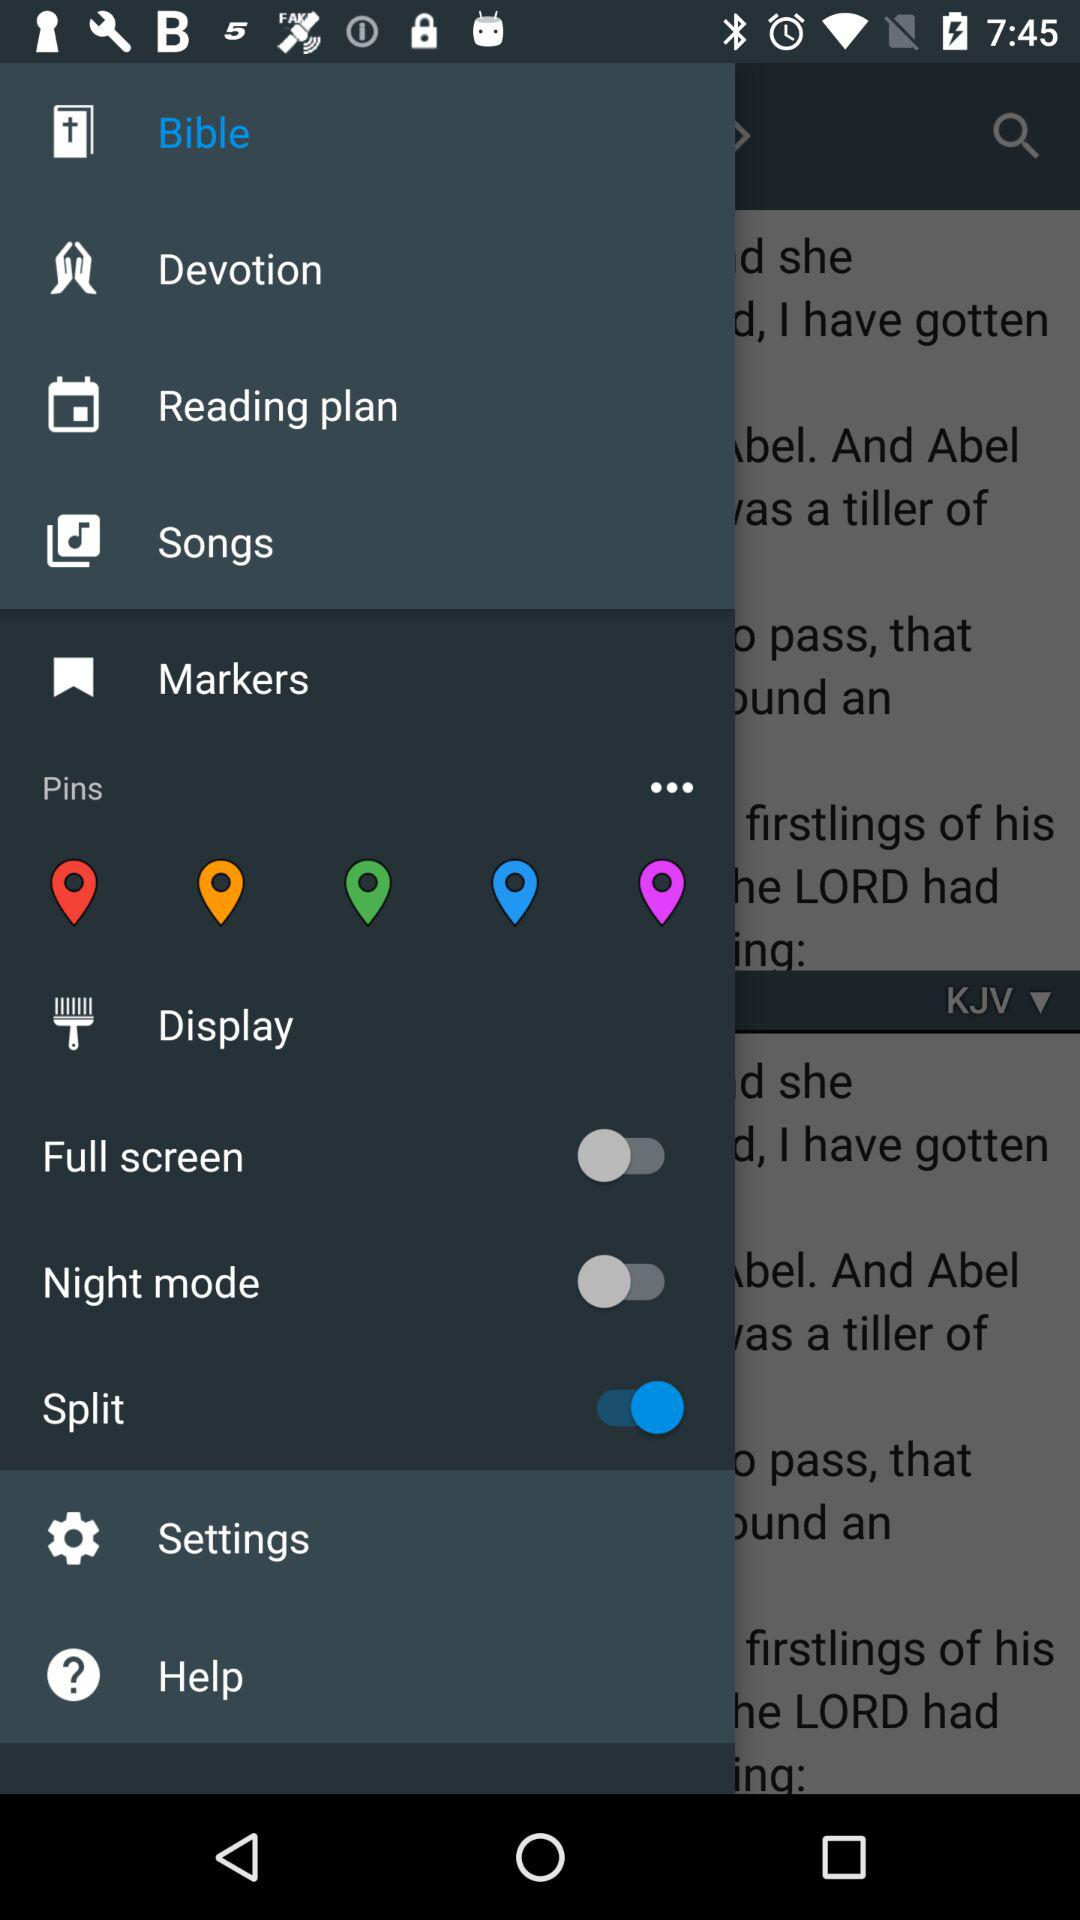What is the status of the full screen? The status is off. 